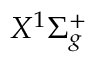Convert formula to latex. <formula><loc_0><loc_0><loc_500><loc_500>X ^ { 1 } \Sigma _ { g } ^ { + }</formula> 